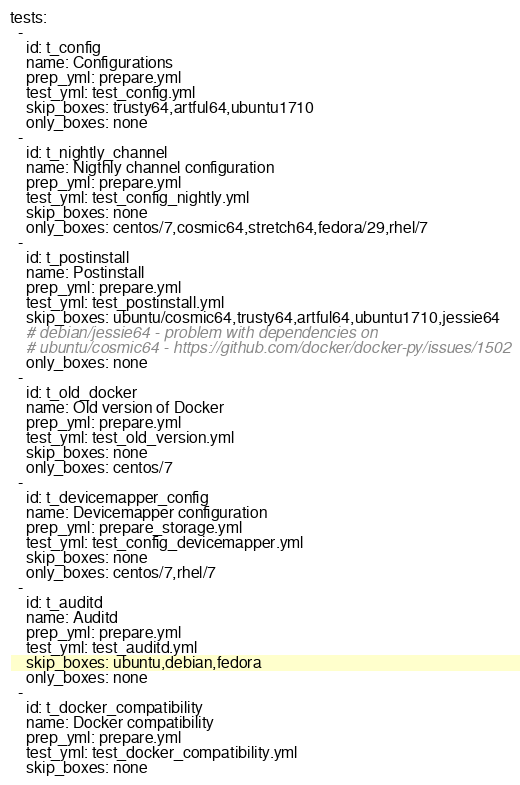Convert code to text. <code><loc_0><loc_0><loc_500><loc_500><_YAML_>tests:
  -
    id: t_config
    name: Configurations
    prep_yml: prepare.yml
    test_yml: test_config.yml
    skip_boxes: trusty64,artful64,ubuntu1710
    only_boxes: none
  -
    id: t_nightly_channel
    name: Nigthly channel configuration
    prep_yml: prepare.yml
    test_yml: test_config_nightly.yml
    skip_boxes: none
    only_boxes: centos/7,cosmic64,stretch64,fedora/29,rhel/7
  -
    id: t_postinstall
    name: Postinstall
    prep_yml: prepare.yml
    test_yml: test_postinstall.yml
    skip_boxes: ubuntu/cosmic64,trusty64,artful64,ubuntu1710,jessie64
    # debian/jessie64 - problem with dependencies on 
    # ubuntu/cosmic64 - https://github.com/docker/docker-py/issues/1502
    only_boxes: none
  -
    id: t_old_docker
    name: Old version of Docker
    prep_yml: prepare.yml
    test_yml: test_old_version.yml
    skip_boxes: none
    only_boxes: centos/7
  -
    id: t_devicemapper_config
    name: Devicemapper configuration
    prep_yml: prepare_storage.yml
    test_yml: test_config_devicemapper.yml
    skip_boxes: none
    only_boxes: centos/7,rhel/7
  -
    id: t_auditd
    name: Auditd
    prep_yml: prepare.yml
    test_yml: test_auditd.yml
    skip_boxes: ubuntu,debian,fedora
    only_boxes: none
  -
    id: t_docker_compatibility
    name: Docker compatibility
    prep_yml: prepare.yml
    test_yml: test_docker_compatibility.yml
    skip_boxes: none</code> 